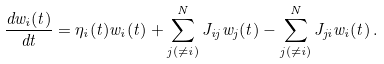Convert formula to latex. <formula><loc_0><loc_0><loc_500><loc_500>\frac { d w _ { i } ( t ) } { d t } = \eta _ { i } ( t ) w _ { i } ( t ) + \sum _ { j ( \ne i ) } ^ { N } J _ { i j } w _ { j } ( t ) - \sum _ { j ( \ne i ) } ^ { N } J _ { j i } w _ { i } ( t ) \, .</formula> 